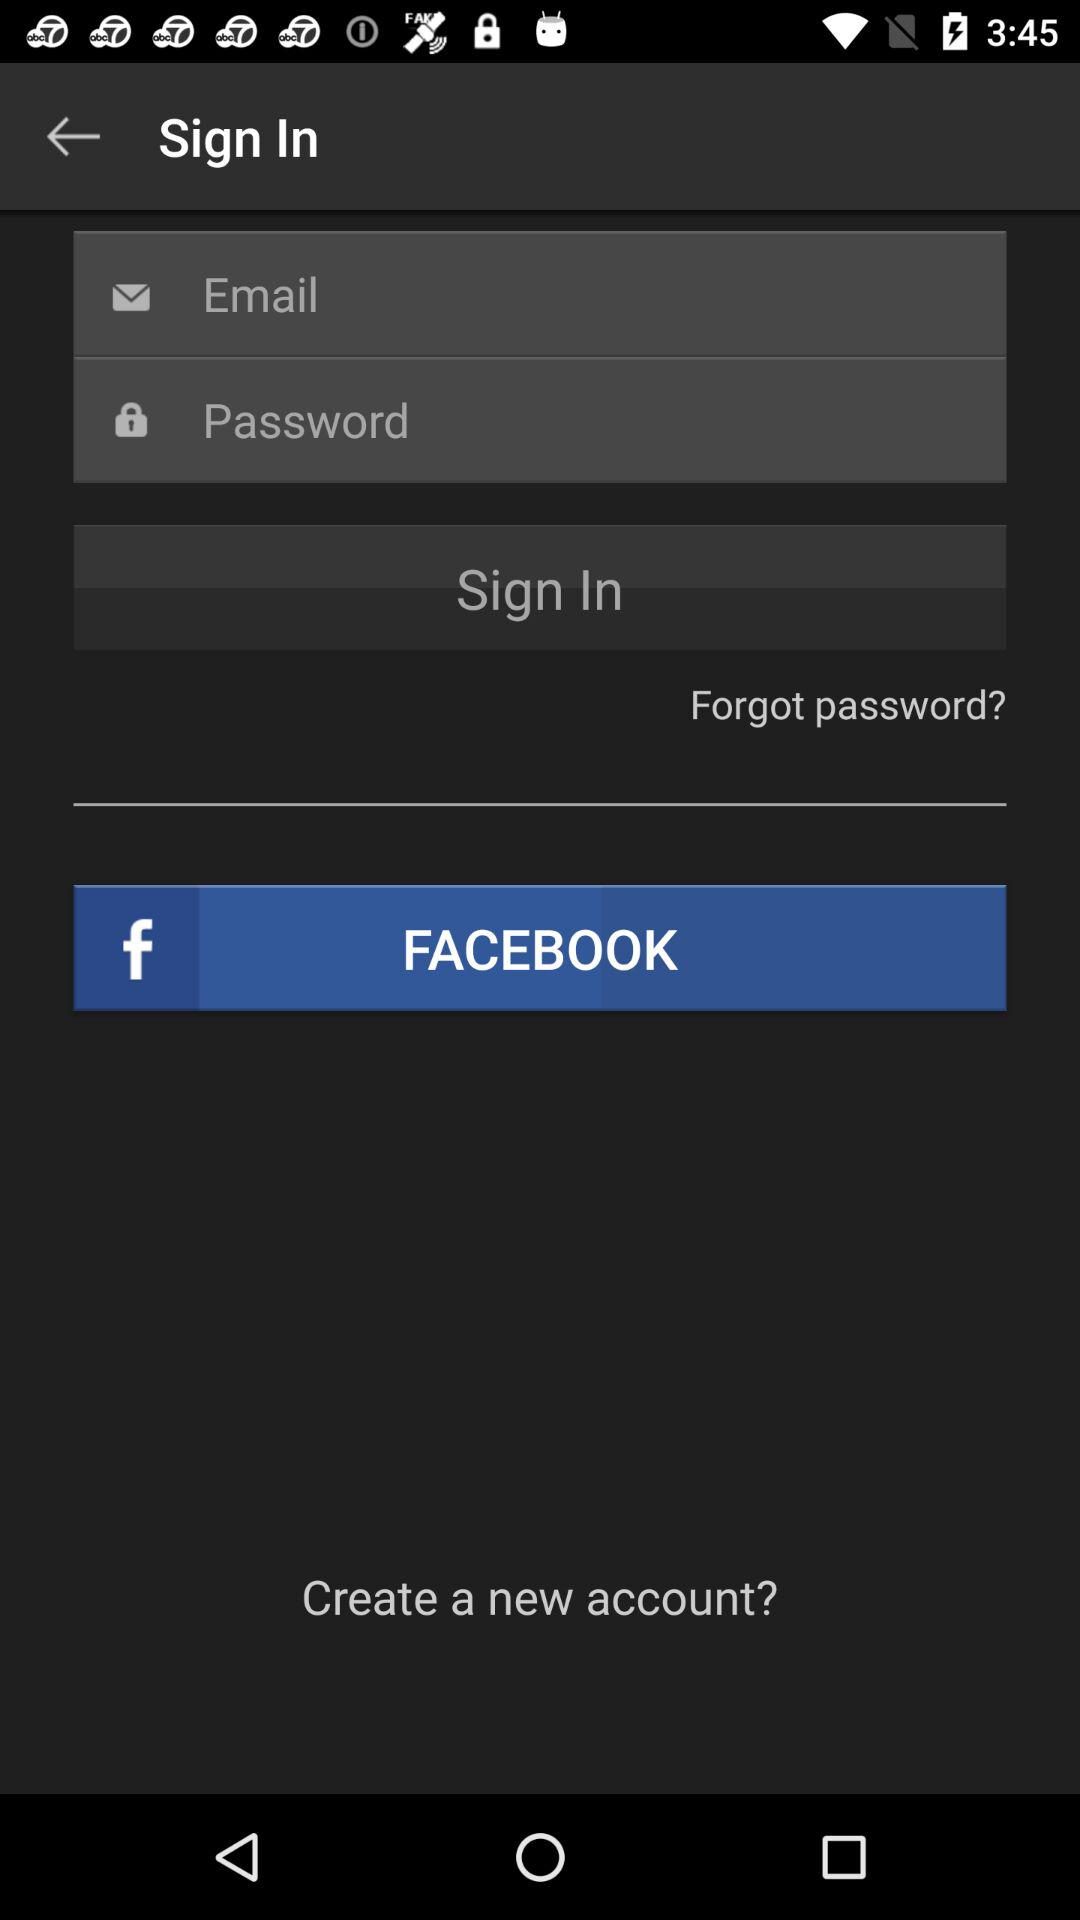Through what application can we sign in to the account? You can sign in with "Email" and "FACEBOOK". 